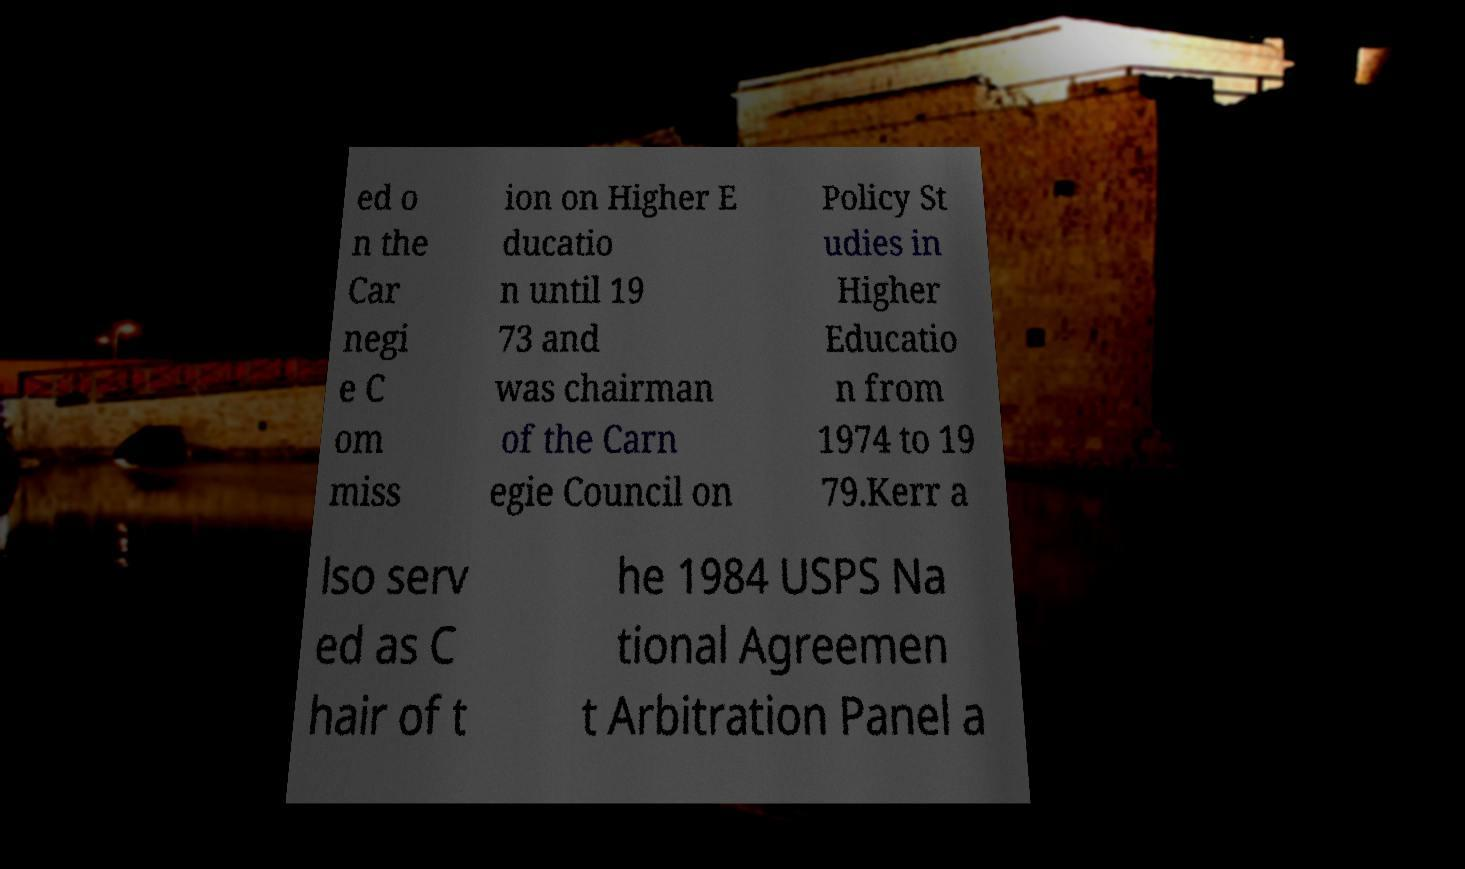I need the written content from this picture converted into text. Can you do that? ed o n the Car negi e C om miss ion on Higher E ducatio n until 19 73 and was chairman of the Carn egie Council on Policy St udies in Higher Educatio n from 1974 to 19 79.Kerr a lso serv ed as C hair of t he 1984 USPS Na tional Agreemen t Arbitration Panel a 